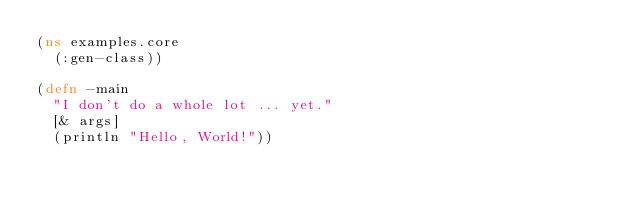<code> <loc_0><loc_0><loc_500><loc_500><_Clojure_>(ns examples.core
  (:gen-class))

(defn -main
  "I don't do a whole lot ... yet."
  [& args]
  (println "Hello, World!"))
</code> 